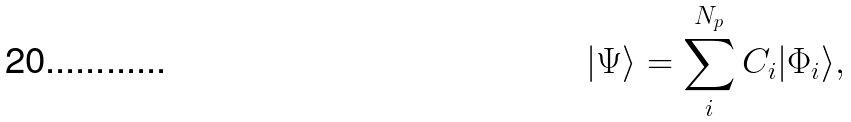<formula> <loc_0><loc_0><loc_500><loc_500>| \Psi \rangle = \sum _ { i } ^ { N _ { p } } C _ { i } | \Phi _ { i } \rangle ,</formula> 